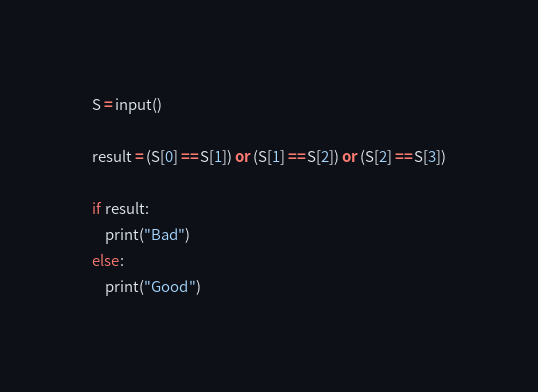<code> <loc_0><loc_0><loc_500><loc_500><_Python_>S = input()

result = (S[0] == S[1]) or (S[1] == S[2]) or (S[2] == S[3])

if result:
    print("Bad")
else:
    print("Good")</code> 